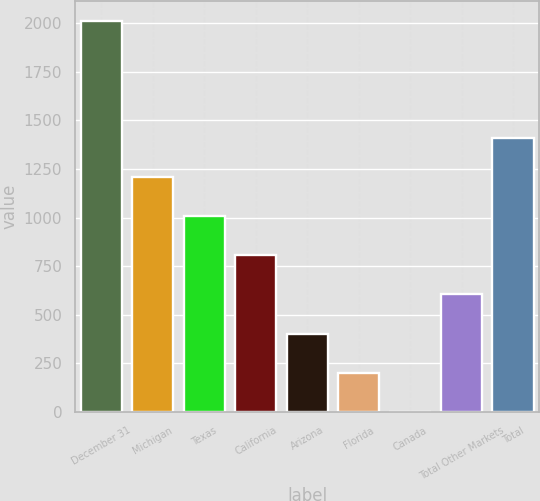Convert chart. <chart><loc_0><loc_0><loc_500><loc_500><bar_chart><fcel>December 31<fcel>Michigan<fcel>Texas<fcel>California<fcel>Arizona<fcel>Florida<fcel>Canada<fcel>Total Other Markets<fcel>Total<nl><fcel>2013<fcel>1208.2<fcel>1007<fcel>805.8<fcel>403.4<fcel>202.2<fcel>1<fcel>604.6<fcel>1409.4<nl></chart> 